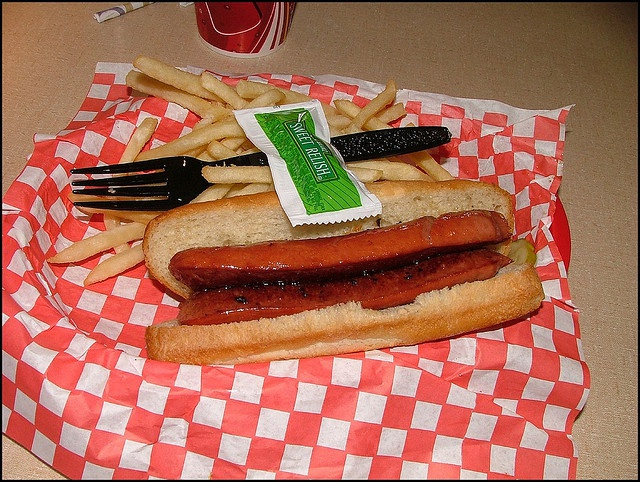Describe the objects in this image and their specific colors. I can see hot dog in black, brown, tan, red, and maroon tones, fork in black, gray, brown, and maroon tones, and cup in black, maroon, brown, and darkgray tones in this image. 